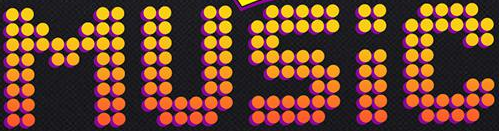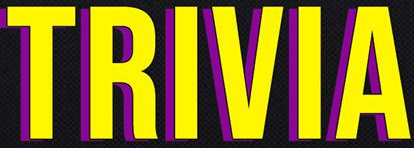Read the text from these images in sequence, separated by a semicolon. MUSIC; TRIVIA 